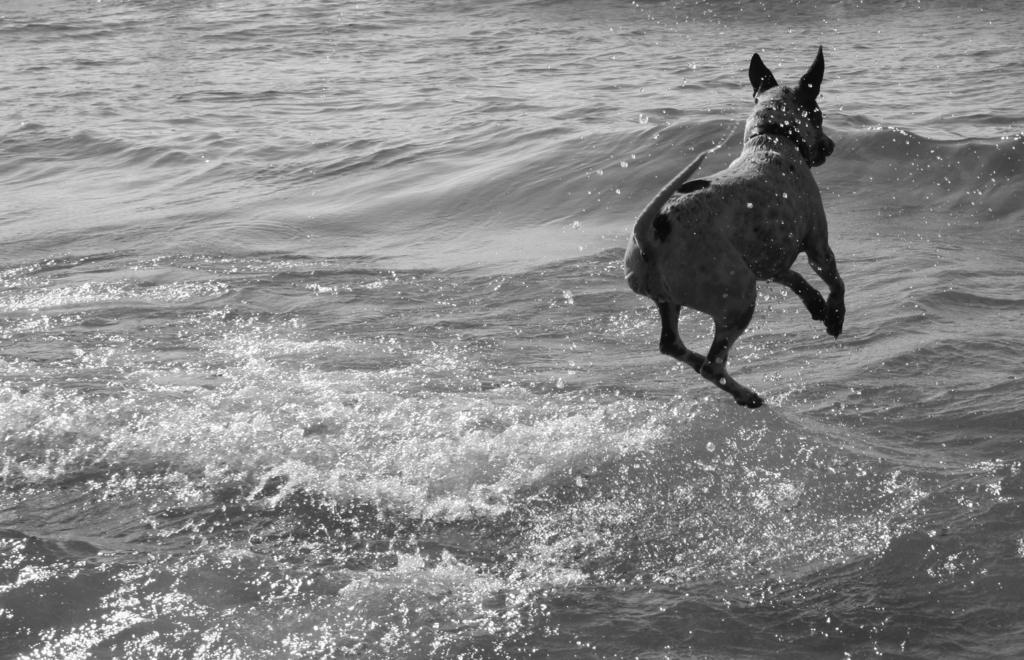Describe this image in one or two sentences. This is a black and white image. In this image there is a dog. At the bottom of the image there is water. 